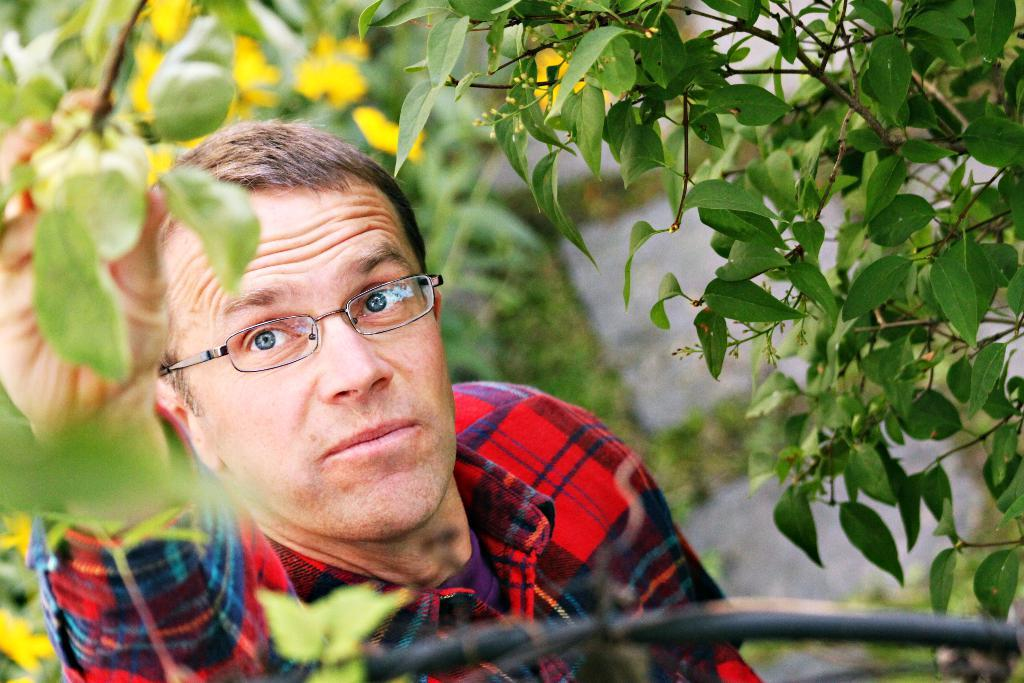Who is present in the image? There is a man in the image. What is the man wearing on his face? The man is wearing spectacles. What type of clothing is the man wearing? The man is wearing a shirt. What can be seen in the background of the image? There are trees and plants in the background of the image. How is the background of the image depicted? The background of the image is blurred. What type of crime is being committed in the image? There is no crime being committed in the image; it features a man wearing spectacles and a shirt, with a blurred background of trees and plants. What is the man eating for dinner in the image? There is no dinner or food visible in the image; it only shows a man wearing spectacles and a shirt, with a blurred background of trees and plants. 